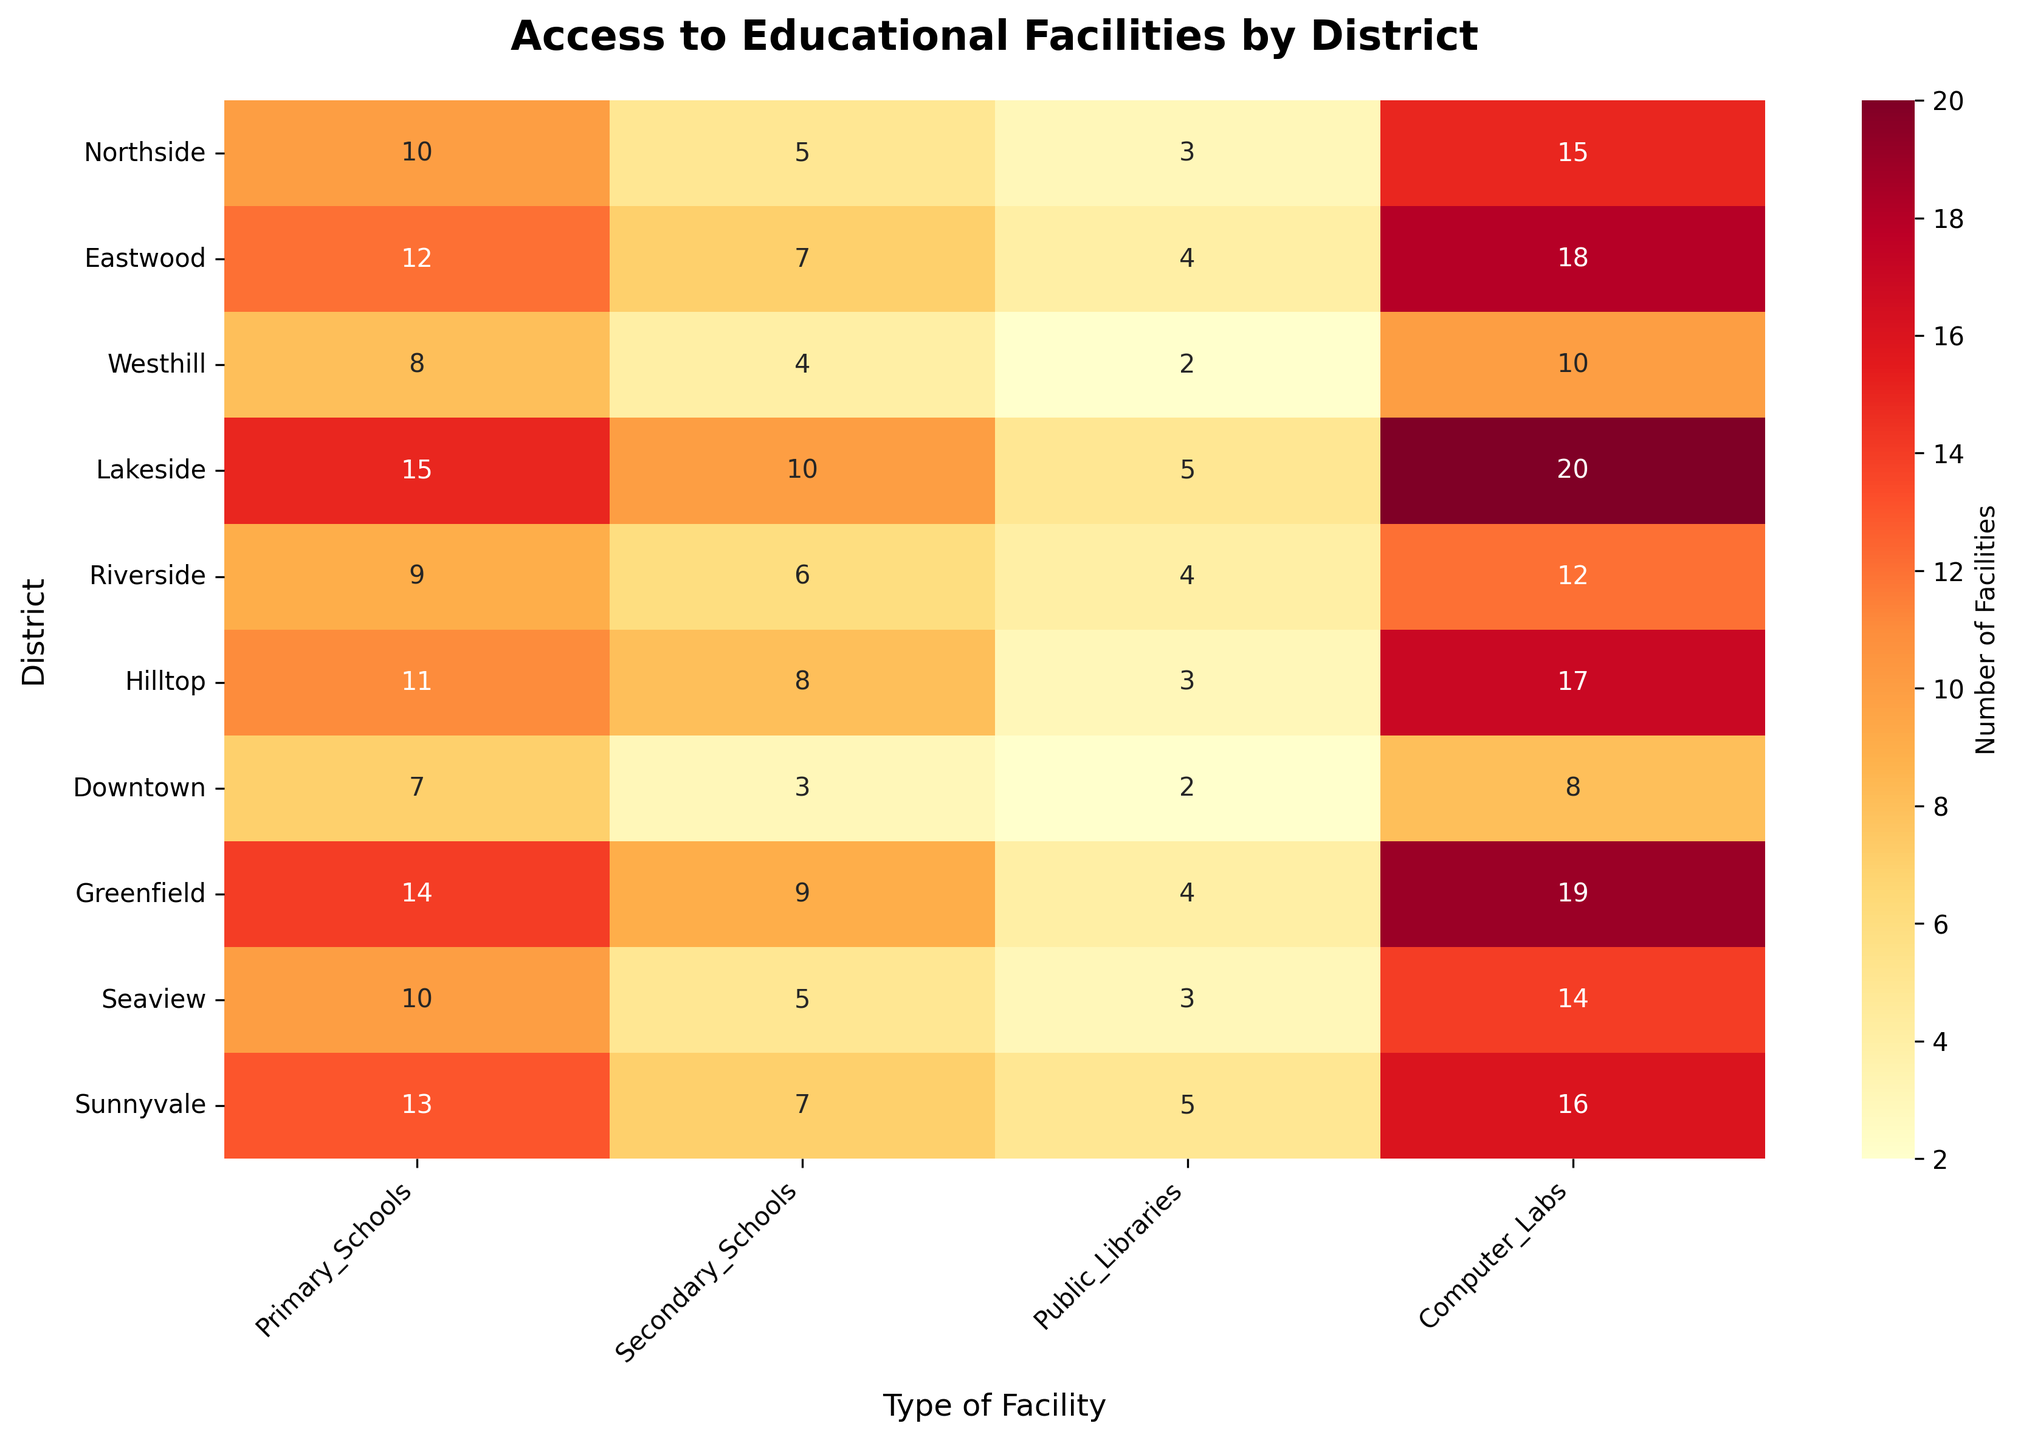what is the title of the figure? The title of a figure is usually found at the top center above the main chart area. It provides a summary of what the figure is about. In this particular figure, the title reads "Access to Educational Facilities by District".
Answer: Access to Educational Facilities by District which district has the highest number of primary schools? To find the district with the highest number of primary schools, look at the column labeled "Primary_Schools" and identify the maximum value. "Lakeside" has 15 primary schools, which is the highest number.
Answer: Lakeside how many total computer labs are available in the Northside and Hilltop districts combined? Sum the number of computer labs in the Northside and Hilltop districts by identifying their values in the "Computer_Labs" column. Northside has 15 and Hilltop has 17, so 15 + 17 = 32.
Answer: 32 which districts have more than 10 primary schools? To find districts with more than 10 primary schools, look for values in the "Primary_Schools" column that are greater than 10. The districts are Eastwood, Lakeside, Hilltop, Greenfield, and Sunnyvale.
Answer: Eastwood, Lakeside, Hilltop, Greenfield, Sunnyvale which district(s) have the same number of public libraries and computer labs? Compare the values in "Public_Libraries" and "Computer_Labs" columns for each district to find matches. Lakeside and Sunnyvale both have 5 public libraries and 5 computer labs.
Answer: Lakeside, Sunnyvale how many districts have an equal number of secondary schools? To find out how many districts have the same number of secondary schools, compare all the values in the "Secondary_Schools" column. "Northside" and "Seaview" both have 5, and "Sunnyvale" and "Eastwood" both have 7. So there are 4 districts with equal secondary schools.
Answer: 4 what is the average number of secondary schools across all districts? Sum the number of secondary schools across all districts and divide by the number of districts. The values are: 5, 7, 4, 10, 6, 8, 3, 9, 5, 7. Sum is 64, and dividing by 10 districts, the average is 64/10 = 6.4.
Answer: 6.4 which district has the least number of educational facilities in total? Calculate the sum of all types of educational facilities for each district and find the smallest one. The calculation is as follows: Northside (10+5+3+15=33), Eastwood (41), Westhill (24), Lakeside (50), Riverside (31), Hilltop (39), Downtown (20), Greenfield (46), Seaview (32), Sunnyvale (41). Downtown has the least with a total of 20.
Answer: Downtown which type of facility has the greatest overall availability among all districts? Sum the values for each type of facility across all districts and compare them. The sums are: Primary Schools (109), Secondary Schools (64), Public Libraries (35), Computer Labs (149). Computer Labs have the highest overall availability.
Answer: Computer Labs 